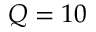Convert formula to latex. <formula><loc_0><loc_0><loc_500><loc_500>Q = 1 0</formula> 